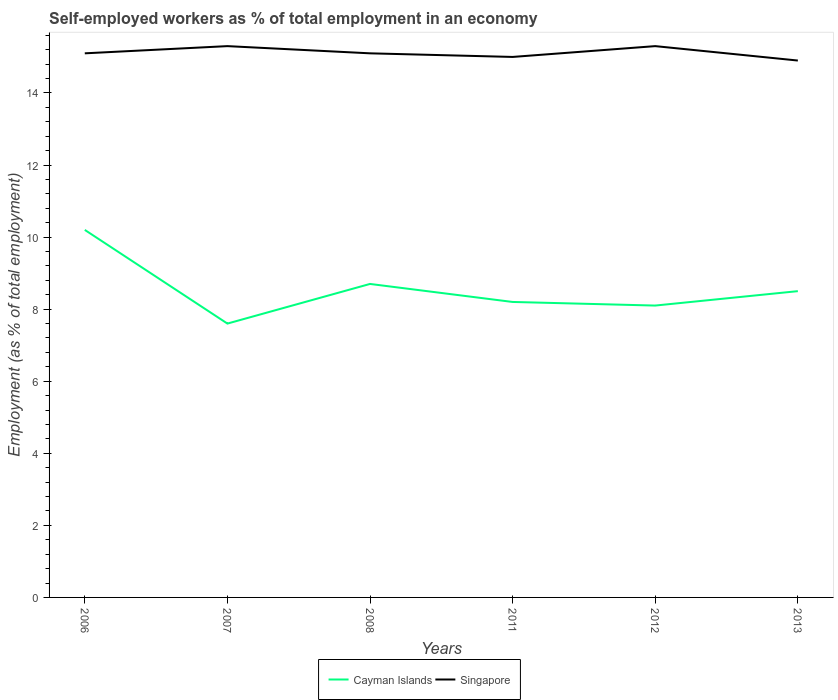Does the line corresponding to Cayman Islands intersect with the line corresponding to Singapore?
Your answer should be very brief. No. Across all years, what is the maximum percentage of self-employed workers in Cayman Islands?
Provide a short and direct response. 7.6. What is the total percentage of self-employed workers in Singapore in the graph?
Give a very brief answer. 0.4. What is the difference between the highest and the second highest percentage of self-employed workers in Cayman Islands?
Your answer should be very brief. 2.6. Is the percentage of self-employed workers in Singapore strictly greater than the percentage of self-employed workers in Cayman Islands over the years?
Provide a succinct answer. No. How many lines are there?
Your answer should be very brief. 2. Does the graph contain any zero values?
Provide a short and direct response. No. Does the graph contain grids?
Ensure brevity in your answer.  No. How many legend labels are there?
Offer a terse response. 2. How are the legend labels stacked?
Your response must be concise. Horizontal. What is the title of the graph?
Give a very brief answer. Self-employed workers as % of total employment in an economy. What is the label or title of the X-axis?
Make the answer very short. Years. What is the label or title of the Y-axis?
Offer a terse response. Employment (as % of total employment). What is the Employment (as % of total employment) in Cayman Islands in 2006?
Make the answer very short. 10.2. What is the Employment (as % of total employment) of Singapore in 2006?
Keep it short and to the point. 15.1. What is the Employment (as % of total employment) of Cayman Islands in 2007?
Offer a very short reply. 7.6. What is the Employment (as % of total employment) in Singapore in 2007?
Your answer should be very brief. 15.3. What is the Employment (as % of total employment) of Cayman Islands in 2008?
Offer a terse response. 8.7. What is the Employment (as % of total employment) in Singapore in 2008?
Keep it short and to the point. 15.1. What is the Employment (as % of total employment) in Cayman Islands in 2011?
Make the answer very short. 8.2. What is the Employment (as % of total employment) in Cayman Islands in 2012?
Your response must be concise. 8.1. What is the Employment (as % of total employment) in Singapore in 2012?
Offer a terse response. 15.3. What is the Employment (as % of total employment) of Cayman Islands in 2013?
Offer a terse response. 8.5. What is the Employment (as % of total employment) in Singapore in 2013?
Your answer should be very brief. 14.9. Across all years, what is the maximum Employment (as % of total employment) of Cayman Islands?
Ensure brevity in your answer.  10.2. Across all years, what is the maximum Employment (as % of total employment) in Singapore?
Make the answer very short. 15.3. Across all years, what is the minimum Employment (as % of total employment) of Cayman Islands?
Your answer should be very brief. 7.6. Across all years, what is the minimum Employment (as % of total employment) of Singapore?
Your answer should be very brief. 14.9. What is the total Employment (as % of total employment) in Cayman Islands in the graph?
Offer a very short reply. 51.3. What is the total Employment (as % of total employment) in Singapore in the graph?
Make the answer very short. 90.7. What is the difference between the Employment (as % of total employment) in Singapore in 2006 and that in 2007?
Offer a very short reply. -0.2. What is the difference between the Employment (as % of total employment) in Cayman Islands in 2006 and that in 2008?
Make the answer very short. 1.5. What is the difference between the Employment (as % of total employment) in Singapore in 2006 and that in 2008?
Give a very brief answer. 0. What is the difference between the Employment (as % of total employment) of Singapore in 2006 and that in 2012?
Your answer should be very brief. -0.2. What is the difference between the Employment (as % of total employment) in Singapore in 2007 and that in 2008?
Make the answer very short. 0.2. What is the difference between the Employment (as % of total employment) of Cayman Islands in 2007 and that in 2011?
Your response must be concise. -0.6. What is the difference between the Employment (as % of total employment) in Singapore in 2007 and that in 2011?
Keep it short and to the point. 0.3. What is the difference between the Employment (as % of total employment) of Singapore in 2007 and that in 2012?
Ensure brevity in your answer.  0. What is the difference between the Employment (as % of total employment) in Singapore in 2007 and that in 2013?
Your response must be concise. 0.4. What is the difference between the Employment (as % of total employment) in Cayman Islands in 2008 and that in 2011?
Make the answer very short. 0.5. What is the difference between the Employment (as % of total employment) in Singapore in 2008 and that in 2011?
Provide a succinct answer. 0.1. What is the difference between the Employment (as % of total employment) in Singapore in 2008 and that in 2012?
Offer a very short reply. -0.2. What is the difference between the Employment (as % of total employment) of Singapore in 2008 and that in 2013?
Offer a terse response. 0.2. What is the difference between the Employment (as % of total employment) of Cayman Islands in 2011 and that in 2012?
Your response must be concise. 0.1. What is the difference between the Employment (as % of total employment) in Singapore in 2011 and that in 2012?
Give a very brief answer. -0.3. What is the difference between the Employment (as % of total employment) in Cayman Islands in 2006 and the Employment (as % of total employment) in Singapore in 2007?
Keep it short and to the point. -5.1. What is the difference between the Employment (as % of total employment) in Cayman Islands in 2006 and the Employment (as % of total employment) in Singapore in 2011?
Your response must be concise. -4.8. What is the difference between the Employment (as % of total employment) of Cayman Islands in 2007 and the Employment (as % of total employment) of Singapore in 2011?
Your response must be concise. -7.4. What is the difference between the Employment (as % of total employment) of Cayman Islands in 2007 and the Employment (as % of total employment) of Singapore in 2013?
Provide a succinct answer. -7.3. What is the difference between the Employment (as % of total employment) of Cayman Islands in 2011 and the Employment (as % of total employment) of Singapore in 2013?
Keep it short and to the point. -6.7. What is the average Employment (as % of total employment) in Cayman Islands per year?
Give a very brief answer. 8.55. What is the average Employment (as % of total employment) in Singapore per year?
Keep it short and to the point. 15.12. In the year 2007, what is the difference between the Employment (as % of total employment) of Cayman Islands and Employment (as % of total employment) of Singapore?
Your response must be concise. -7.7. In the year 2008, what is the difference between the Employment (as % of total employment) of Cayman Islands and Employment (as % of total employment) of Singapore?
Provide a succinct answer. -6.4. In the year 2011, what is the difference between the Employment (as % of total employment) in Cayman Islands and Employment (as % of total employment) in Singapore?
Offer a terse response. -6.8. In the year 2012, what is the difference between the Employment (as % of total employment) in Cayman Islands and Employment (as % of total employment) in Singapore?
Give a very brief answer. -7.2. In the year 2013, what is the difference between the Employment (as % of total employment) of Cayman Islands and Employment (as % of total employment) of Singapore?
Your response must be concise. -6.4. What is the ratio of the Employment (as % of total employment) of Cayman Islands in 2006 to that in 2007?
Provide a succinct answer. 1.34. What is the ratio of the Employment (as % of total employment) of Singapore in 2006 to that in 2007?
Give a very brief answer. 0.99. What is the ratio of the Employment (as % of total employment) of Cayman Islands in 2006 to that in 2008?
Keep it short and to the point. 1.17. What is the ratio of the Employment (as % of total employment) in Cayman Islands in 2006 to that in 2011?
Provide a succinct answer. 1.24. What is the ratio of the Employment (as % of total employment) of Singapore in 2006 to that in 2011?
Provide a short and direct response. 1.01. What is the ratio of the Employment (as % of total employment) in Cayman Islands in 2006 to that in 2012?
Provide a short and direct response. 1.26. What is the ratio of the Employment (as % of total employment) of Singapore in 2006 to that in 2012?
Ensure brevity in your answer.  0.99. What is the ratio of the Employment (as % of total employment) of Cayman Islands in 2006 to that in 2013?
Keep it short and to the point. 1.2. What is the ratio of the Employment (as % of total employment) of Singapore in 2006 to that in 2013?
Keep it short and to the point. 1.01. What is the ratio of the Employment (as % of total employment) of Cayman Islands in 2007 to that in 2008?
Offer a terse response. 0.87. What is the ratio of the Employment (as % of total employment) in Singapore in 2007 to that in 2008?
Keep it short and to the point. 1.01. What is the ratio of the Employment (as % of total employment) in Cayman Islands in 2007 to that in 2011?
Provide a succinct answer. 0.93. What is the ratio of the Employment (as % of total employment) of Cayman Islands in 2007 to that in 2012?
Ensure brevity in your answer.  0.94. What is the ratio of the Employment (as % of total employment) of Cayman Islands in 2007 to that in 2013?
Your answer should be compact. 0.89. What is the ratio of the Employment (as % of total employment) of Singapore in 2007 to that in 2013?
Offer a terse response. 1.03. What is the ratio of the Employment (as % of total employment) of Cayman Islands in 2008 to that in 2011?
Your response must be concise. 1.06. What is the ratio of the Employment (as % of total employment) in Singapore in 2008 to that in 2011?
Offer a very short reply. 1.01. What is the ratio of the Employment (as % of total employment) of Cayman Islands in 2008 to that in 2012?
Give a very brief answer. 1.07. What is the ratio of the Employment (as % of total employment) in Singapore in 2008 to that in 2012?
Keep it short and to the point. 0.99. What is the ratio of the Employment (as % of total employment) of Cayman Islands in 2008 to that in 2013?
Offer a very short reply. 1.02. What is the ratio of the Employment (as % of total employment) in Singapore in 2008 to that in 2013?
Ensure brevity in your answer.  1.01. What is the ratio of the Employment (as % of total employment) in Cayman Islands in 2011 to that in 2012?
Provide a short and direct response. 1.01. What is the ratio of the Employment (as % of total employment) of Singapore in 2011 to that in 2012?
Offer a very short reply. 0.98. What is the ratio of the Employment (as % of total employment) of Cayman Islands in 2011 to that in 2013?
Your answer should be very brief. 0.96. What is the ratio of the Employment (as % of total employment) in Cayman Islands in 2012 to that in 2013?
Give a very brief answer. 0.95. What is the ratio of the Employment (as % of total employment) in Singapore in 2012 to that in 2013?
Your answer should be compact. 1.03. What is the difference between the highest and the lowest Employment (as % of total employment) of Cayman Islands?
Your answer should be compact. 2.6. 